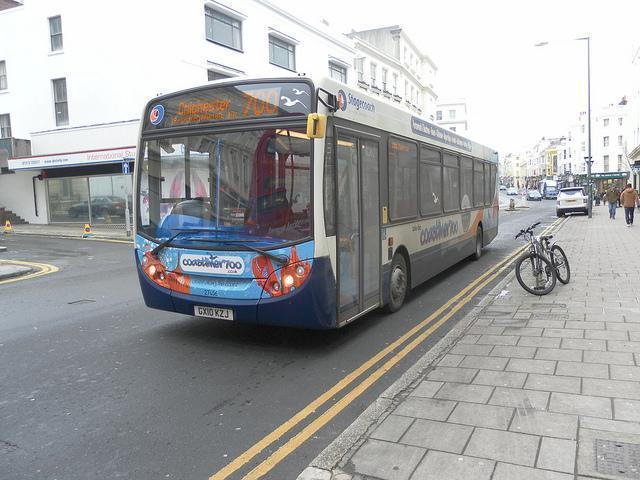Which vehicle has violated the law?
Pick the right solution, then justify: 'Answer: answer
Rationale: rationale.'
Options: White car, black car, bicycle, bus. Answer: white car.
Rationale: It is parked on the sidewalk 